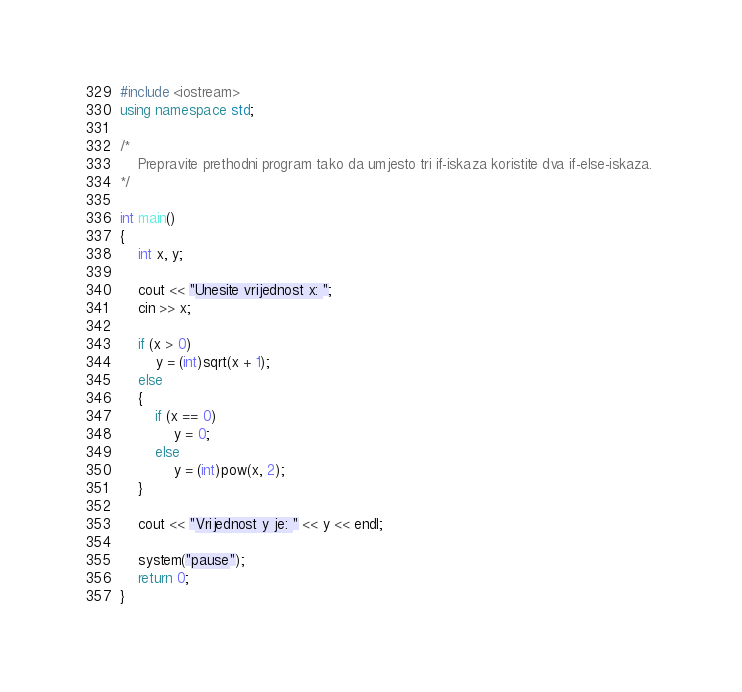Convert code to text. <code><loc_0><loc_0><loc_500><loc_500><_C++_>#include <iostream>
using namespace std;

/*
	Prepravite prethodni program tako da umjesto tri if-iskaza koristite dva if-else-iskaza. 
*/

int main()
{
	int x, y;

	cout << "Unesite vrijednost x: ";
	cin >> x;

	if (x > 0)
		y = (int)sqrt(x + 1);
	else
	{
		if (x == 0)
			y = 0;
		else
			y = (int)pow(x, 2);
	}

	cout << "Vrijednost y je: " << y << endl;

	system("pause");
	return 0;
}</code> 